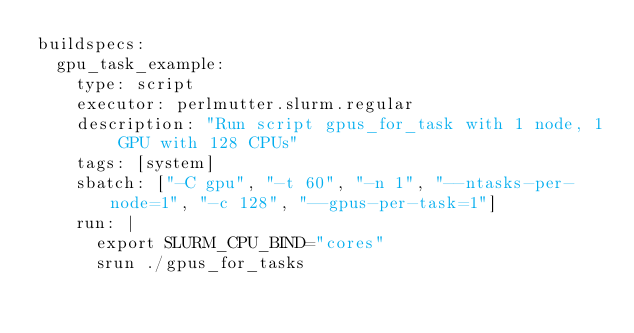Convert code to text. <code><loc_0><loc_0><loc_500><loc_500><_YAML_>buildspecs:
  gpu_task_example: 
    type: script
    executor: perlmutter.slurm.regular
    description: "Run script gpus_for_task with 1 node, 1 GPU with 128 CPUs"
    tags: [system]
    sbatch: ["-C gpu", "-t 60", "-n 1", "--ntasks-per-node=1", "-c 128", "--gpus-per-task=1"]
    run: |
      export SLURM_CPU_BIND="cores"
      srun ./gpus_for_tasks
</code> 